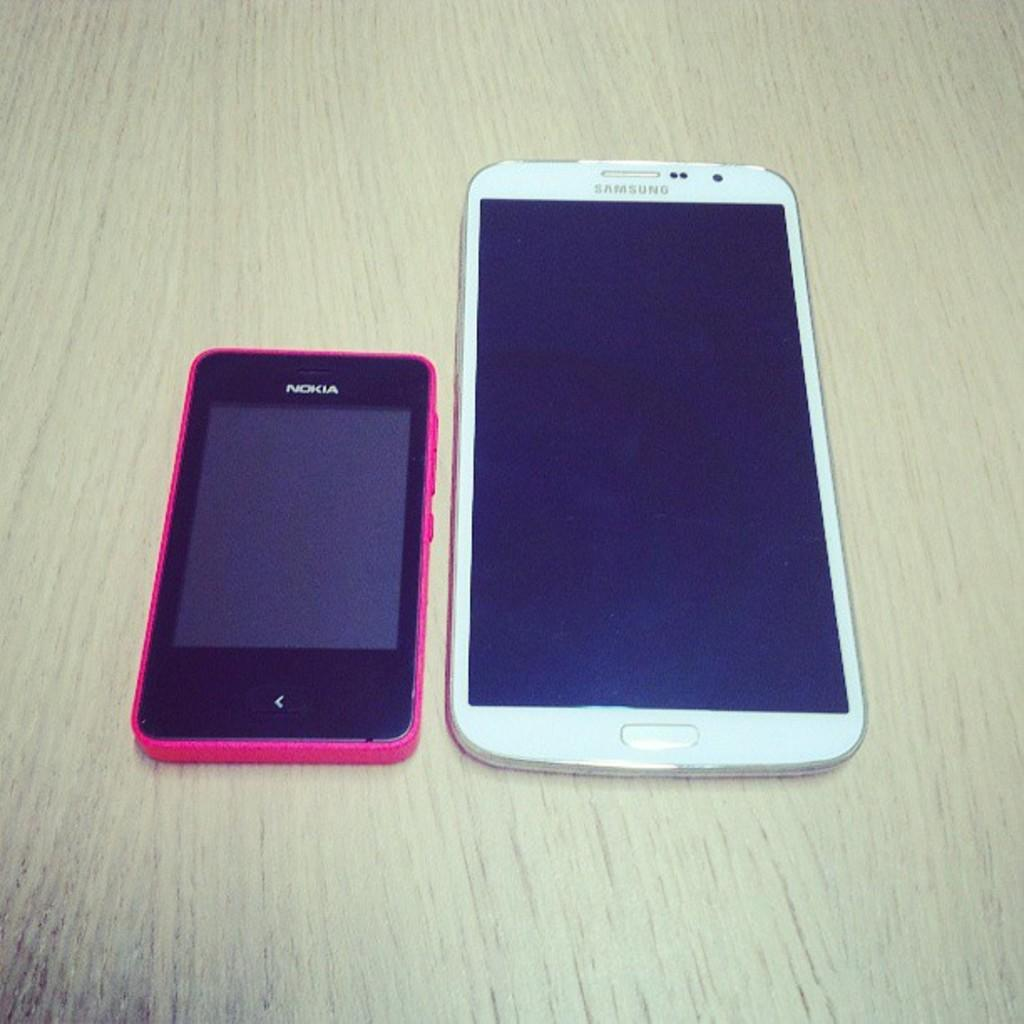<image>
Render a clear and concise summary of the photo. A larger white Samsung phone rests next to a small Nokia phone. 